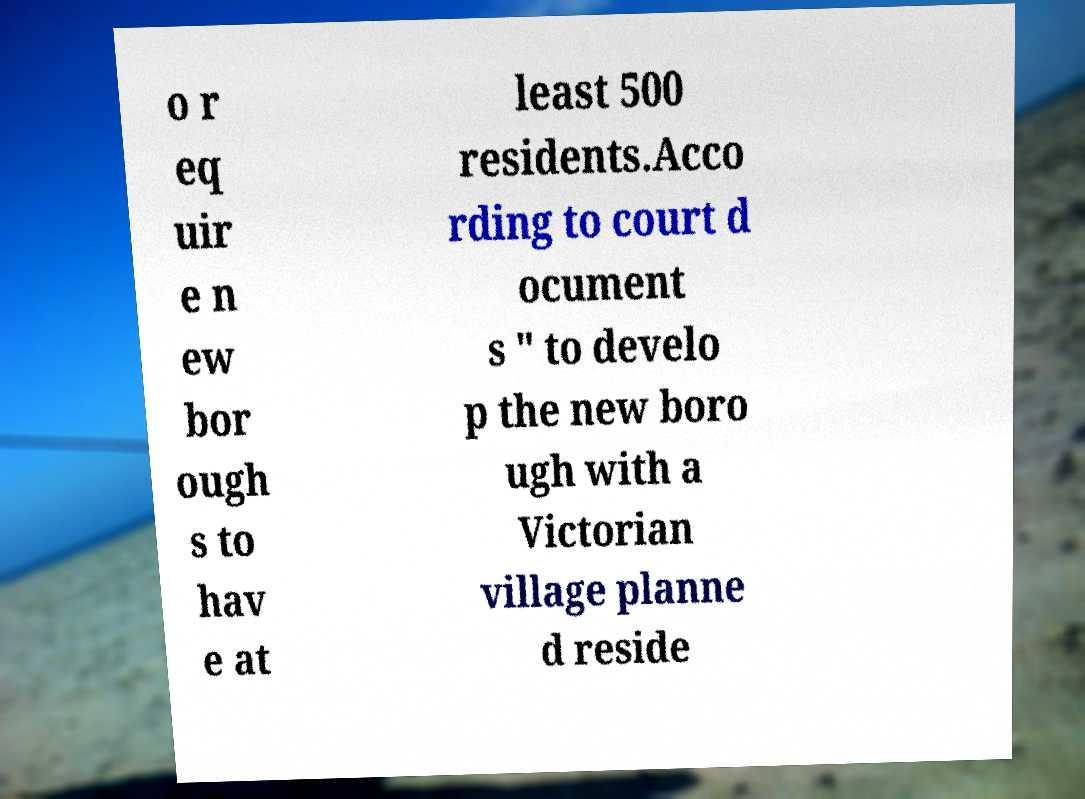There's text embedded in this image that I need extracted. Can you transcribe it verbatim? o r eq uir e n ew bor ough s to hav e at least 500 residents.Acco rding to court d ocument s " to develo p the new boro ugh with a Victorian village planne d reside 